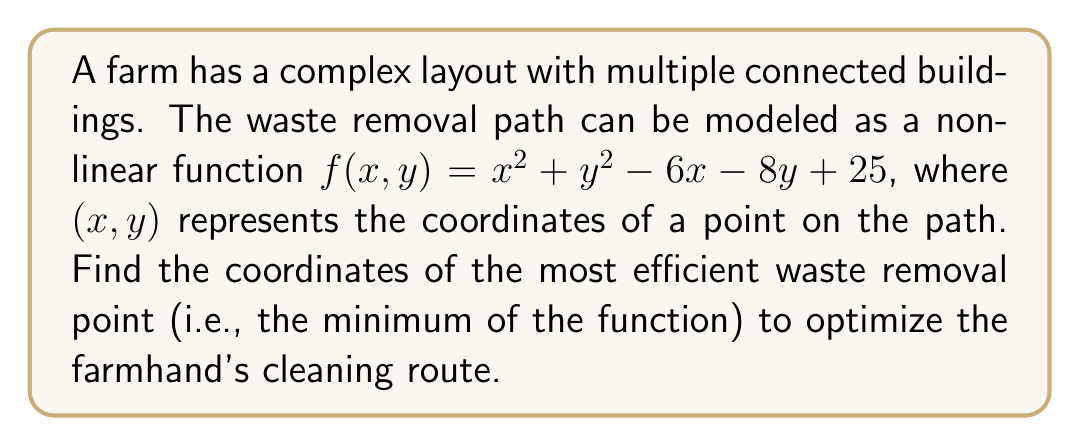Can you answer this question? To find the most efficient waste removal point, we need to locate the minimum of the given function $f(x,y) = x^2 + y^2 - 6x - 8y + 25$. This can be done by following these steps:

1. Calculate the partial derivatives of $f$ with respect to $x$ and $y$:
   $$\frac{\partial f}{\partial x} = 2x - 6$$
   $$\frac{\partial f}{\partial y} = 2y - 8$$

2. Set both partial derivatives to zero to find the critical point:
   $$2x - 6 = 0$$
   $$2y - 8 = 0$$

3. Solve the system of equations:
   $$x = 3$$
   $$y = 4$$

4. Verify that this critical point is indeed a minimum by checking the second partial derivatives:
   $$\frac{\partial^2 f}{\partial x^2} = 2 > 0$$
   $$\frac{\partial^2 f}{\partial y^2} = 2 > 0$$
   $$\frac{\partial^2 f}{\partial x \partial y} = 0$$

   The Hessian matrix is positive definite, confirming that (3, 4) is a local minimum.

5. Since the function is convex (opens upward in all directions), this local minimum is also the global minimum.

Therefore, the most efficient waste removal point is at the coordinates (3, 4).
Answer: (3, 4) 